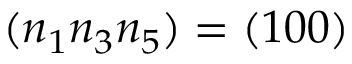Convert formula to latex. <formula><loc_0><loc_0><loc_500><loc_500>( n _ { 1 } n _ { 3 } n _ { 5 } ) = ( 1 0 0 )</formula> 